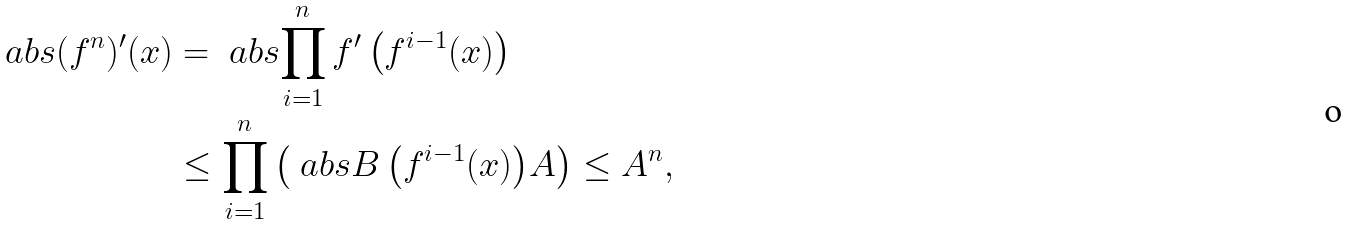<formula> <loc_0><loc_0><loc_500><loc_500>\ a b s { ( f ^ { n } ) ^ { \prime } ( x ) } & = \ a b s { \prod _ { i = 1 } ^ { n } f ^ { \prime } \left ( f ^ { i - 1 } ( x ) \right ) } \\ & \leq \prod _ { i = 1 } ^ { n } \left ( \ a b s { B \left ( f ^ { i - 1 } ( x ) \right ) } A \right ) \leq A ^ { n } ,</formula> 